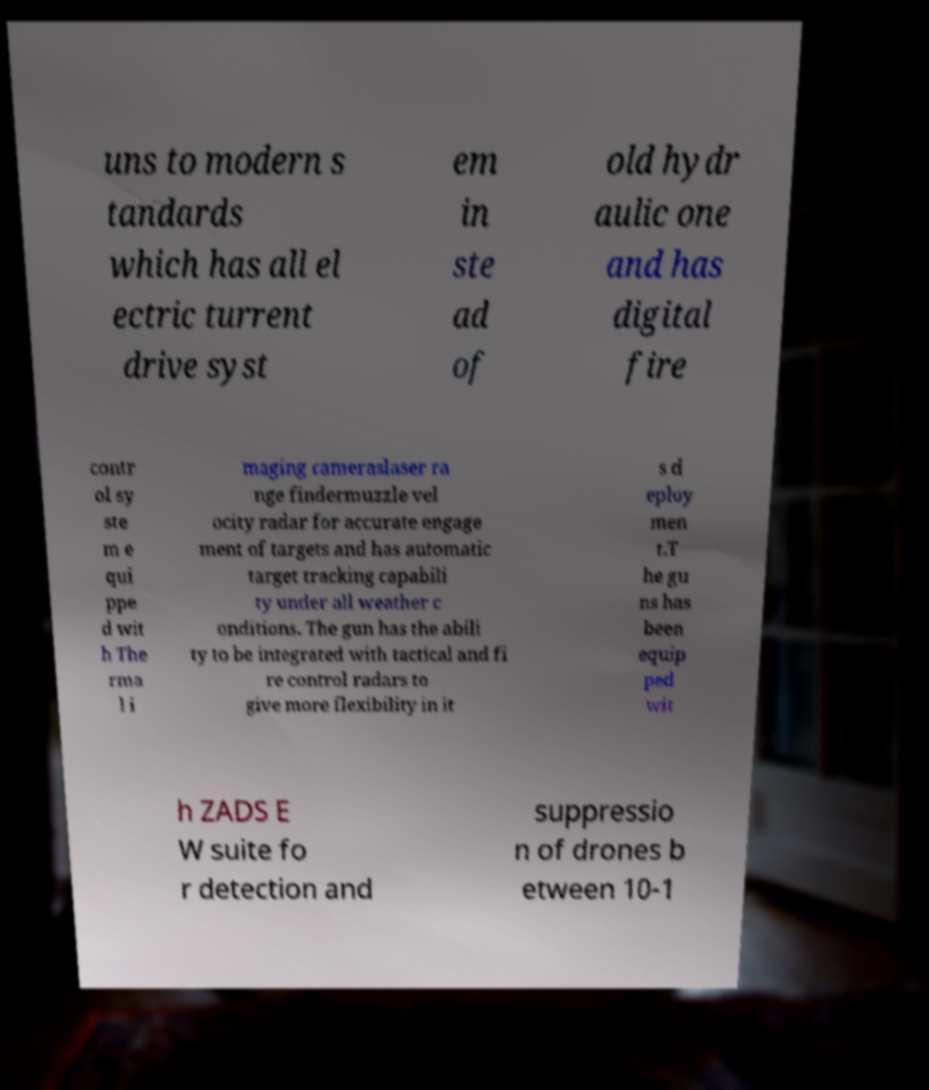Please identify and transcribe the text found in this image. uns to modern s tandards which has all el ectric turrent drive syst em in ste ad of old hydr aulic one and has digital fire contr ol sy ste m e qui ppe d wit h The rma l i maging cameraslaser ra nge findermuzzle vel ocity radar for accurate engage ment of targets and has automatic target tracking capabili ty under all weather c onditions. The gun has the abili ty to be integrated with tactical and fi re control radars to give more flexibility in it s d eploy men t.T he gu ns has been equip ped wit h ZADS E W suite fo r detection and suppressio n of drones b etween 10-1 